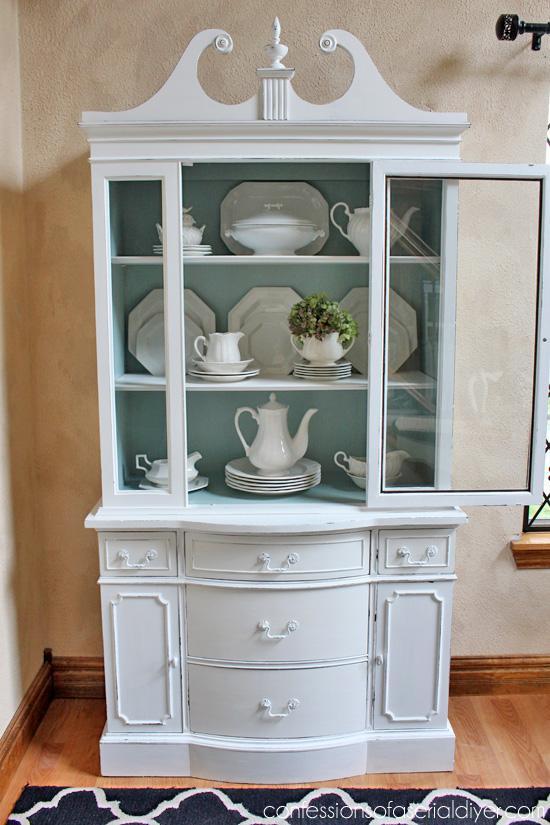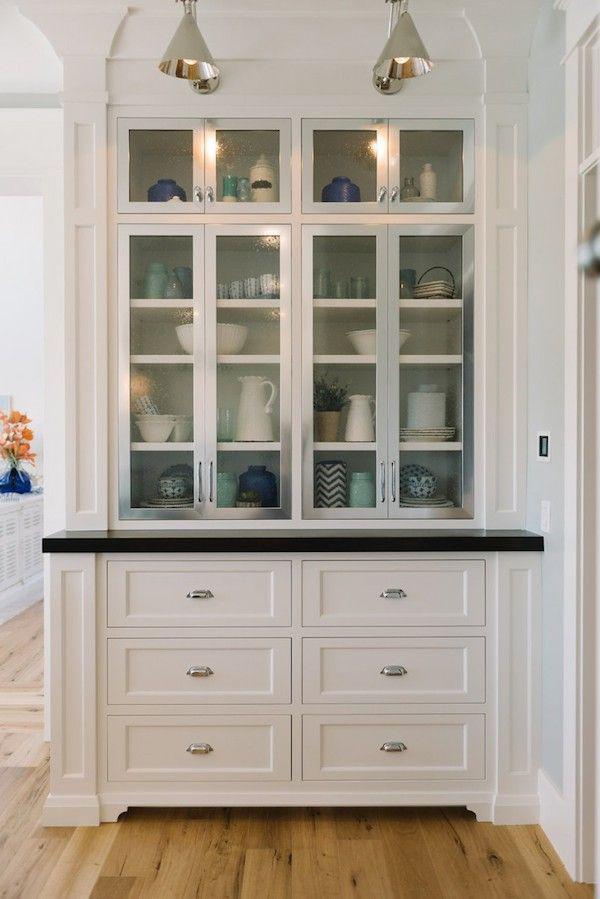The first image is the image on the left, the second image is the image on the right. For the images displayed, is the sentence "The white cabinet on the left has an ornate, curved top piece" factually correct? Answer yes or no. Yes. The first image is the image on the left, the second image is the image on the right. Considering the images on both sides, is "The top of one cabinet is not flat, and features two curl shapes that face each other." valid? Answer yes or no. Yes. 